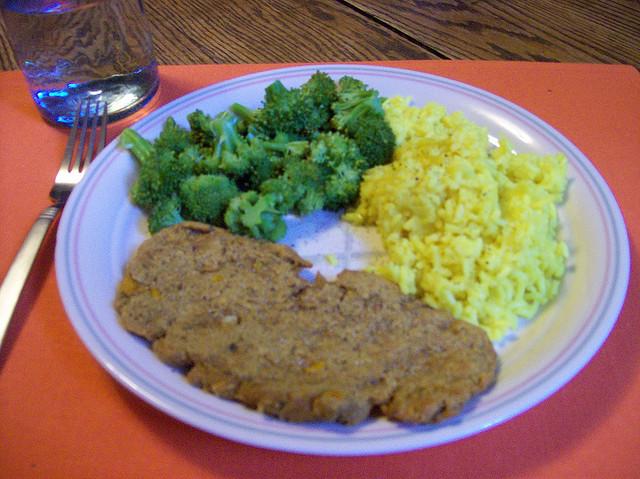What color is the plate?
Give a very brief answer. White. What kind of rice is in the bowl?
Keep it brief. Yellow. How many different types of foods are here?
Quick response, please. 3. What is silver in this photo?
Concise answer only. Fork. What kind of meat is this?
Answer briefly. Steak. 